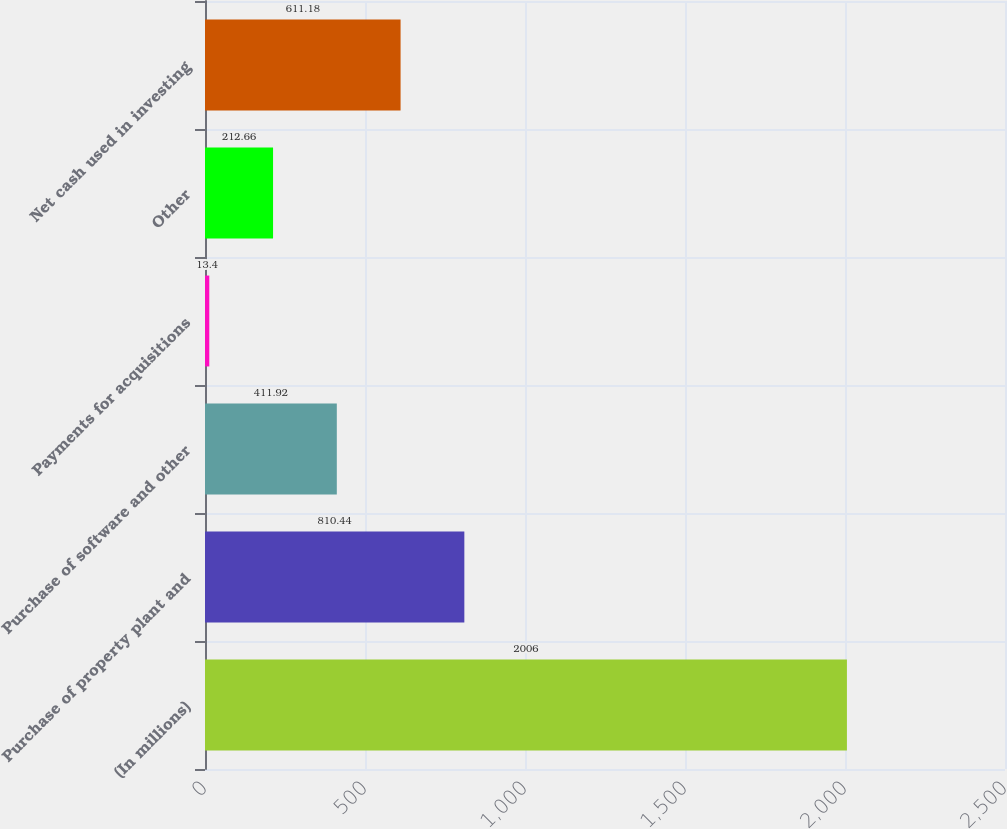Convert chart. <chart><loc_0><loc_0><loc_500><loc_500><bar_chart><fcel>(In millions)<fcel>Purchase of property plant and<fcel>Purchase of software and other<fcel>Payments for acquisitions<fcel>Other<fcel>Net cash used in investing<nl><fcel>2006<fcel>810.44<fcel>411.92<fcel>13.4<fcel>212.66<fcel>611.18<nl></chart> 